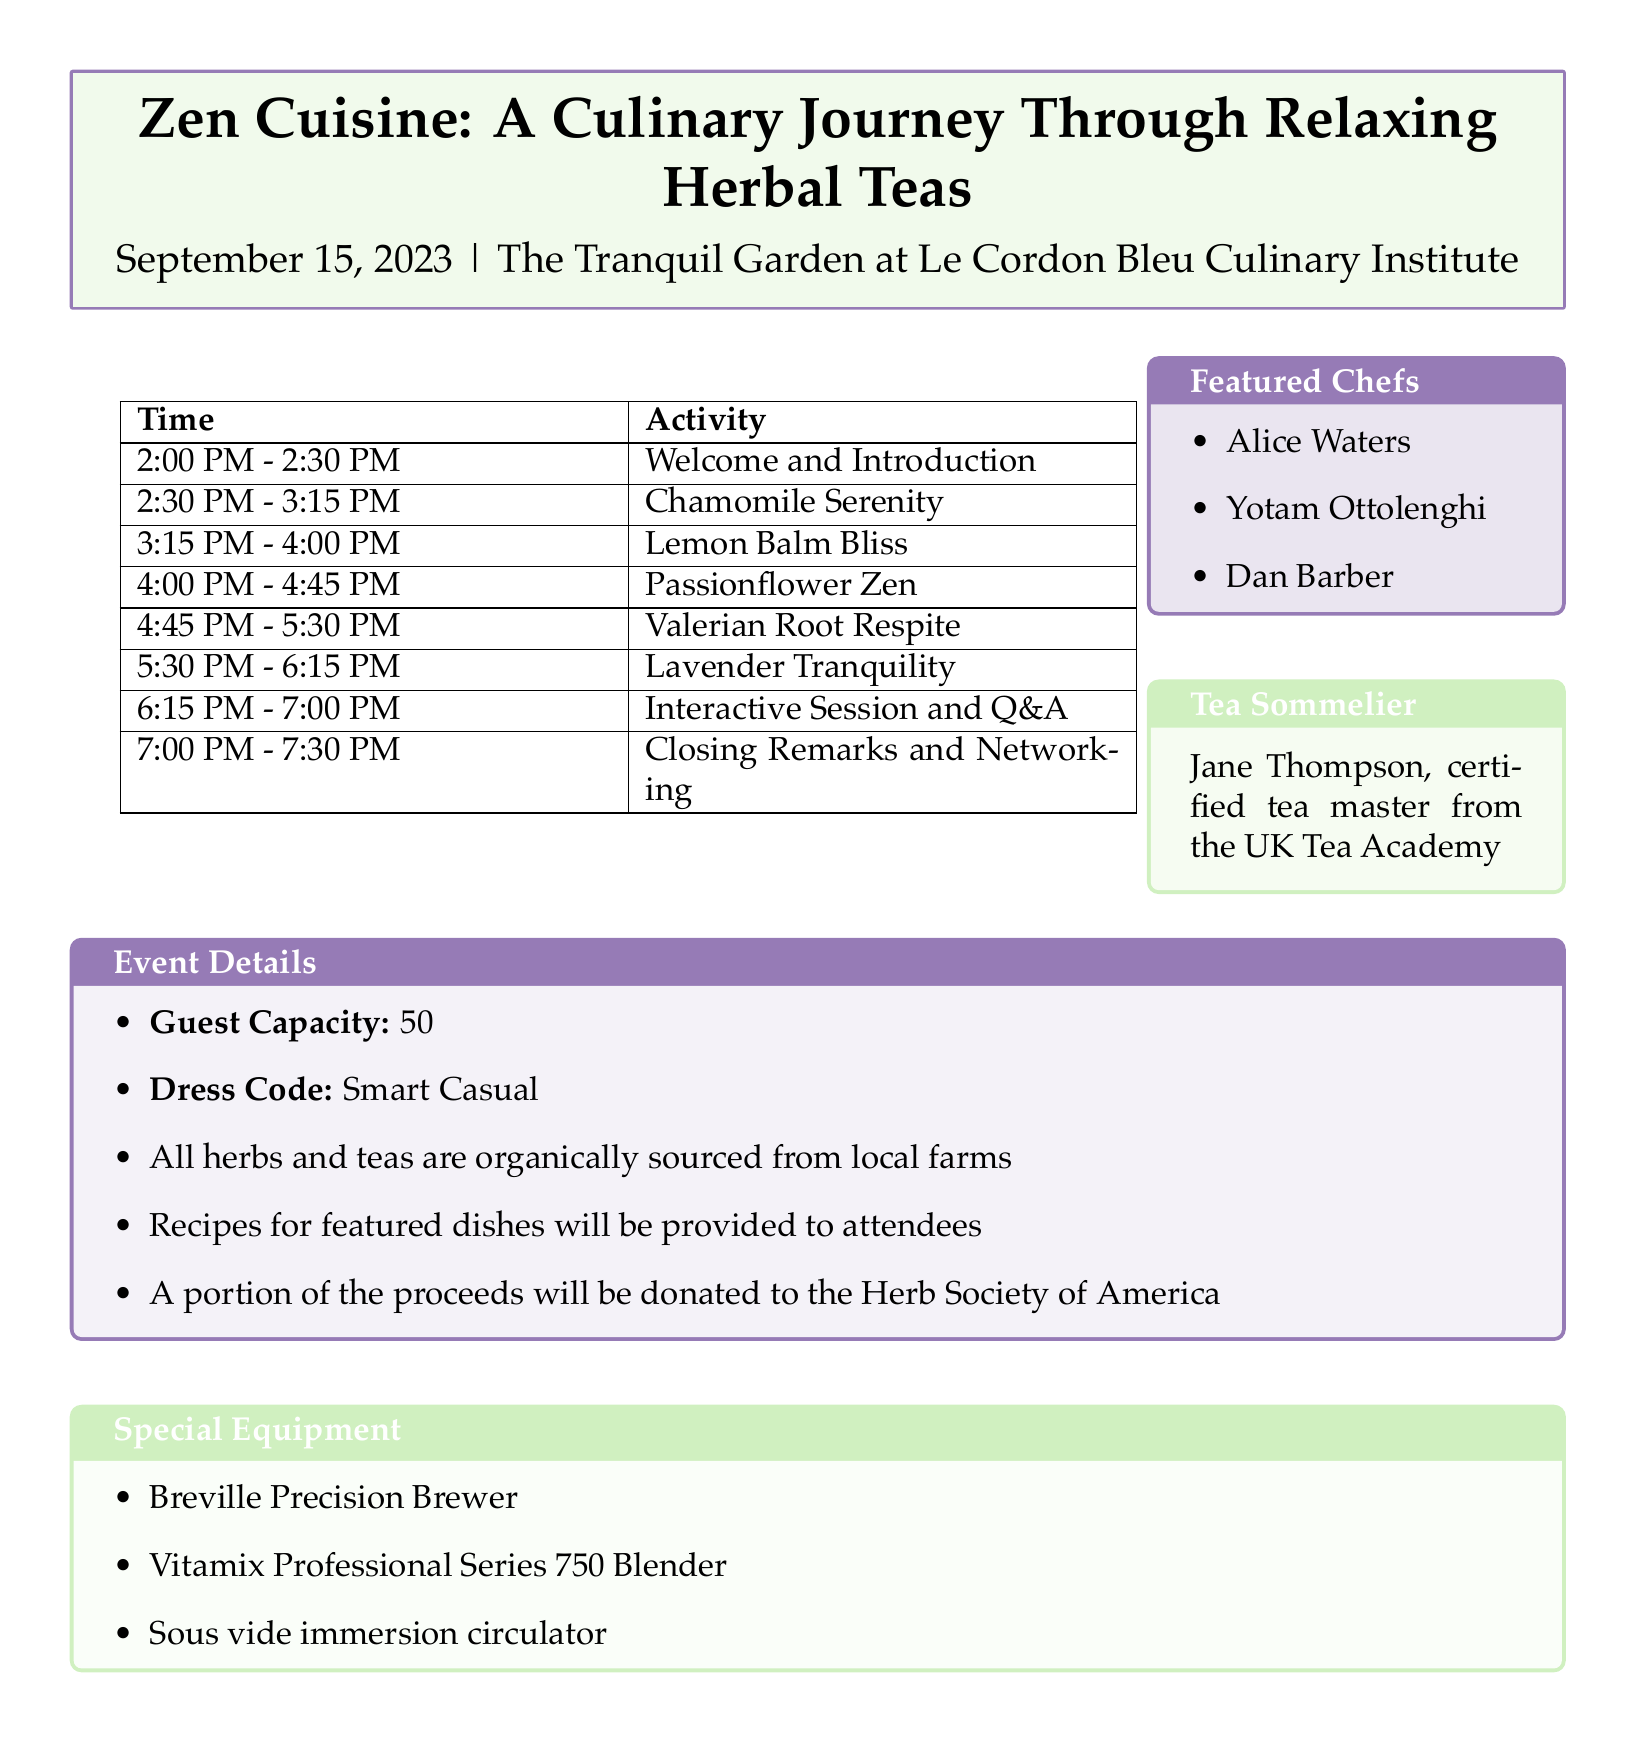What is the title of the event? The title of the event is mentioned in the document as "Zen Cuisine: A Culinary Journey Through Relaxing Herbal Teas".
Answer: Zen Cuisine: A Culinary Journey Through Relaxing Herbal Teas Who is the tea sommelier for the event? The document lists Jane Thompson as the certified tea master from the UK Tea Academy, who is the tea sommelier.
Answer: Jane Thompson What is the date of the event? The date is explicitly stated in the document as September 15, 2023.
Answer: September 15, 2023 How many featured chefs are listed in the document? The document provides a list of three featured chefs: Alice Waters, Yotam Ottolenghi, and Dan Barber.
Answer: 3 What is the guest capacity for the event? The document specifies the guest capacity as 50.
Answer: 50 What activity takes place from 4:00 PM to 4:45 PM? The document describes the activity "Passionflower Zen" during that time slot.
Answer: Passionflower Zen Which culinary demonstration accompanies the "Chamomile Serenity" tasting? The document states that the live preparation of honey-chamomile sorbet accompanies the "Chamomile Serenity" tasting.
Answer: Live preparation of honey-chamomile sorbet What portion of the proceeds will be donated? The document mentions that a portion of the proceeds will be donated to the Herb Society of America.
Answer: Herb Society of America 